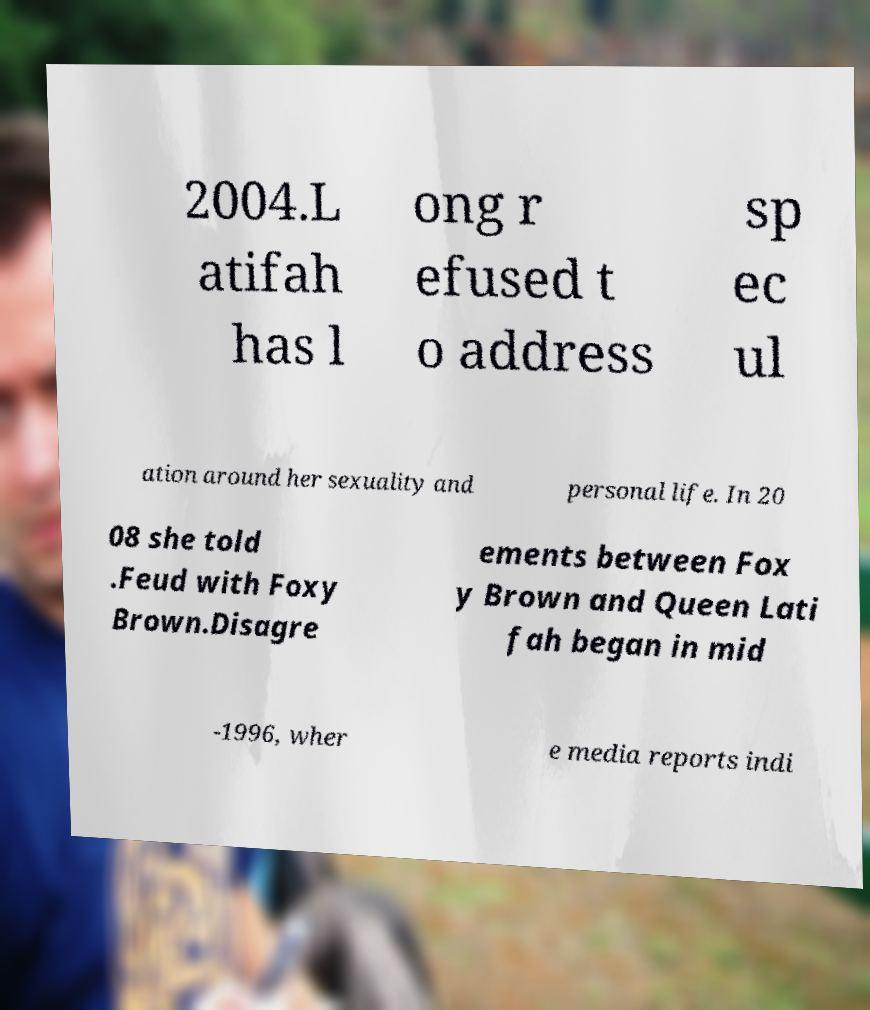I need the written content from this picture converted into text. Can you do that? 2004.L atifah has l ong r efused t o address sp ec ul ation around her sexuality and personal life. In 20 08 she told .Feud with Foxy Brown.Disagre ements between Fox y Brown and Queen Lati fah began in mid -1996, wher e media reports indi 